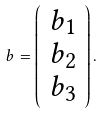<formula> <loc_0><loc_0><loc_500><loc_500>b = \left ( \begin{array} { c } b _ { 1 } \\ b _ { 2 } \\ b _ { 3 } \end{array} \right ) .</formula> 